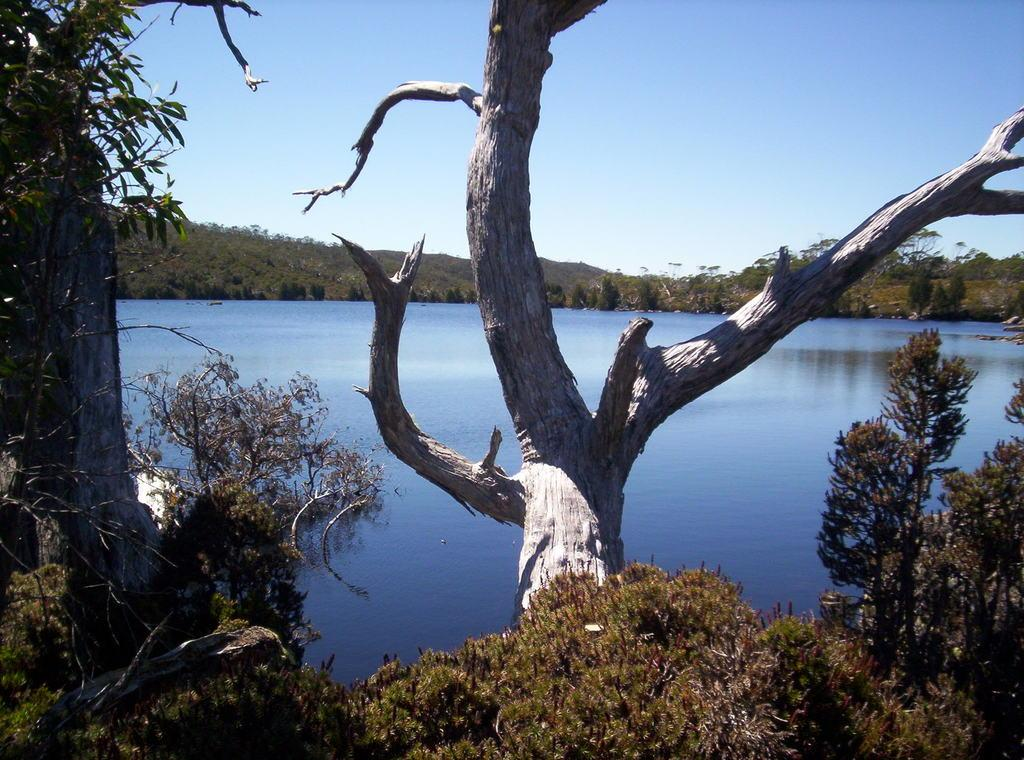What type of vegetation can be seen in the image? There are trees in the image. What body of water is present in the image? There is a lake in the image. What is the long, thin part of a plant that connects the leaves to the stem? The stem is visible in the image. What is visible at the top of the image? The sky is visible at the top of the image. Can you tell me how many flowers are depicted in the image? There are no flowers present in the image; it features trees and a lake. What type of porter is carrying the lake in the image? There is no porter present in the image, as the lake is a natural body of water. 